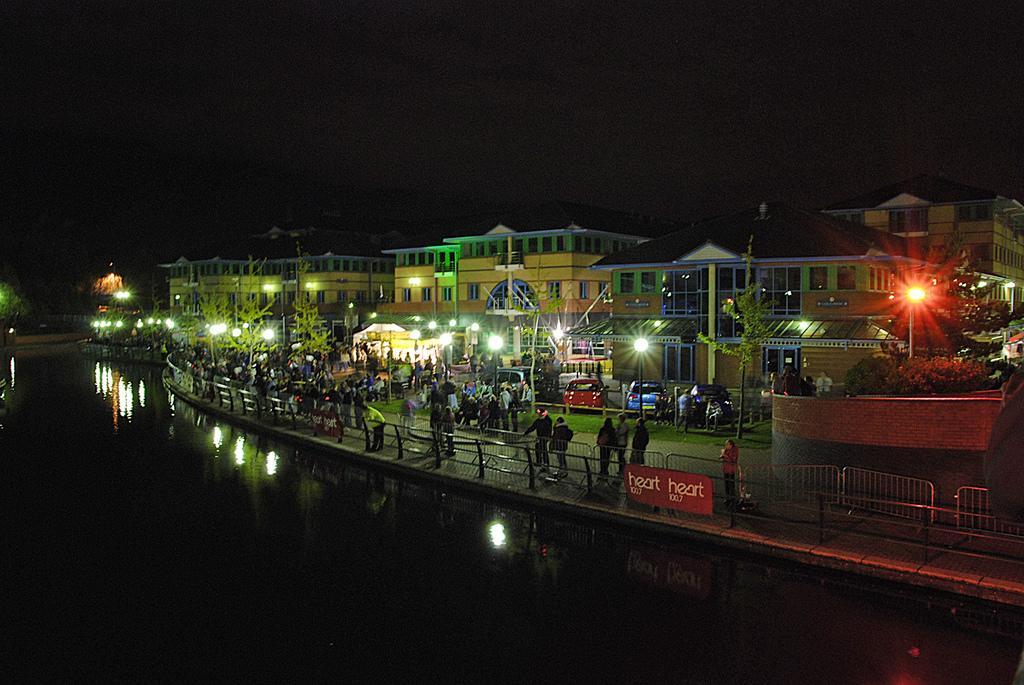Please provide a concise description of this image. In this picture we can see a group of people, vehicles on the ground, fence, name board, water, lights poles, trees, buildings with windows, some objects and in the background it is dark. 